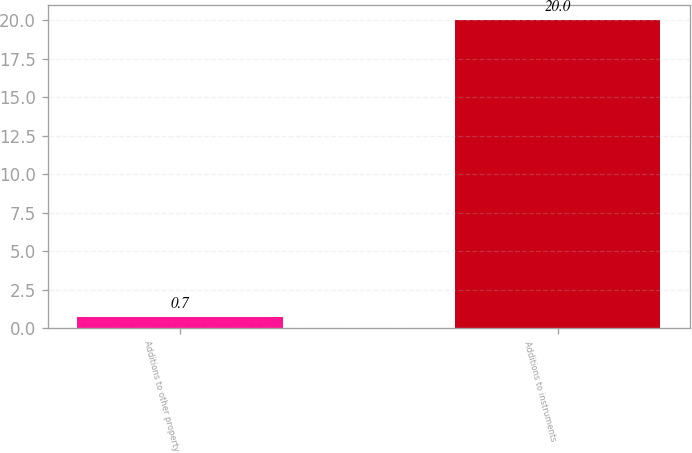Convert chart. <chart><loc_0><loc_0><loc_500><loc_500><bar_chart><fcel>Additions to other property<fcel>Additions to instruments<nl><fcel>0.7<fcel>20<nl></chart> 